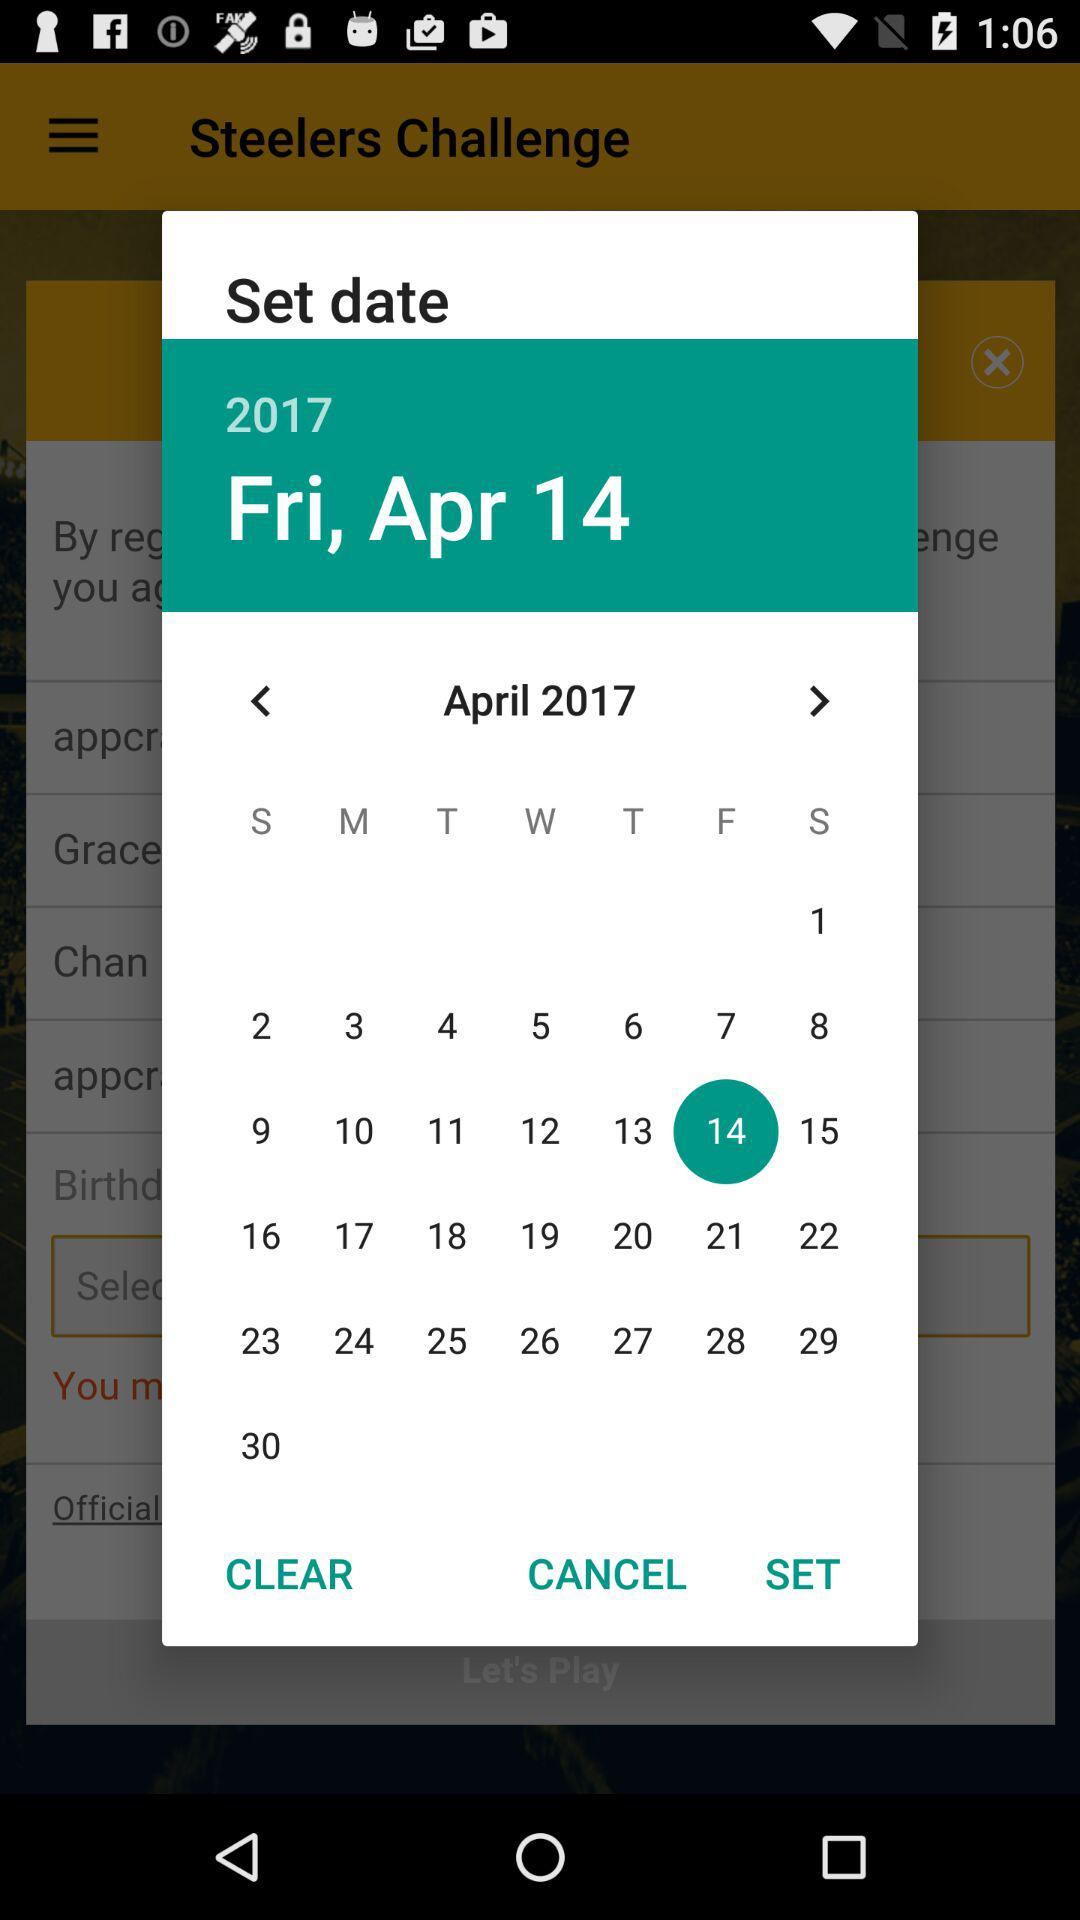Which month calendar it is? The calendar is for the month of April. 